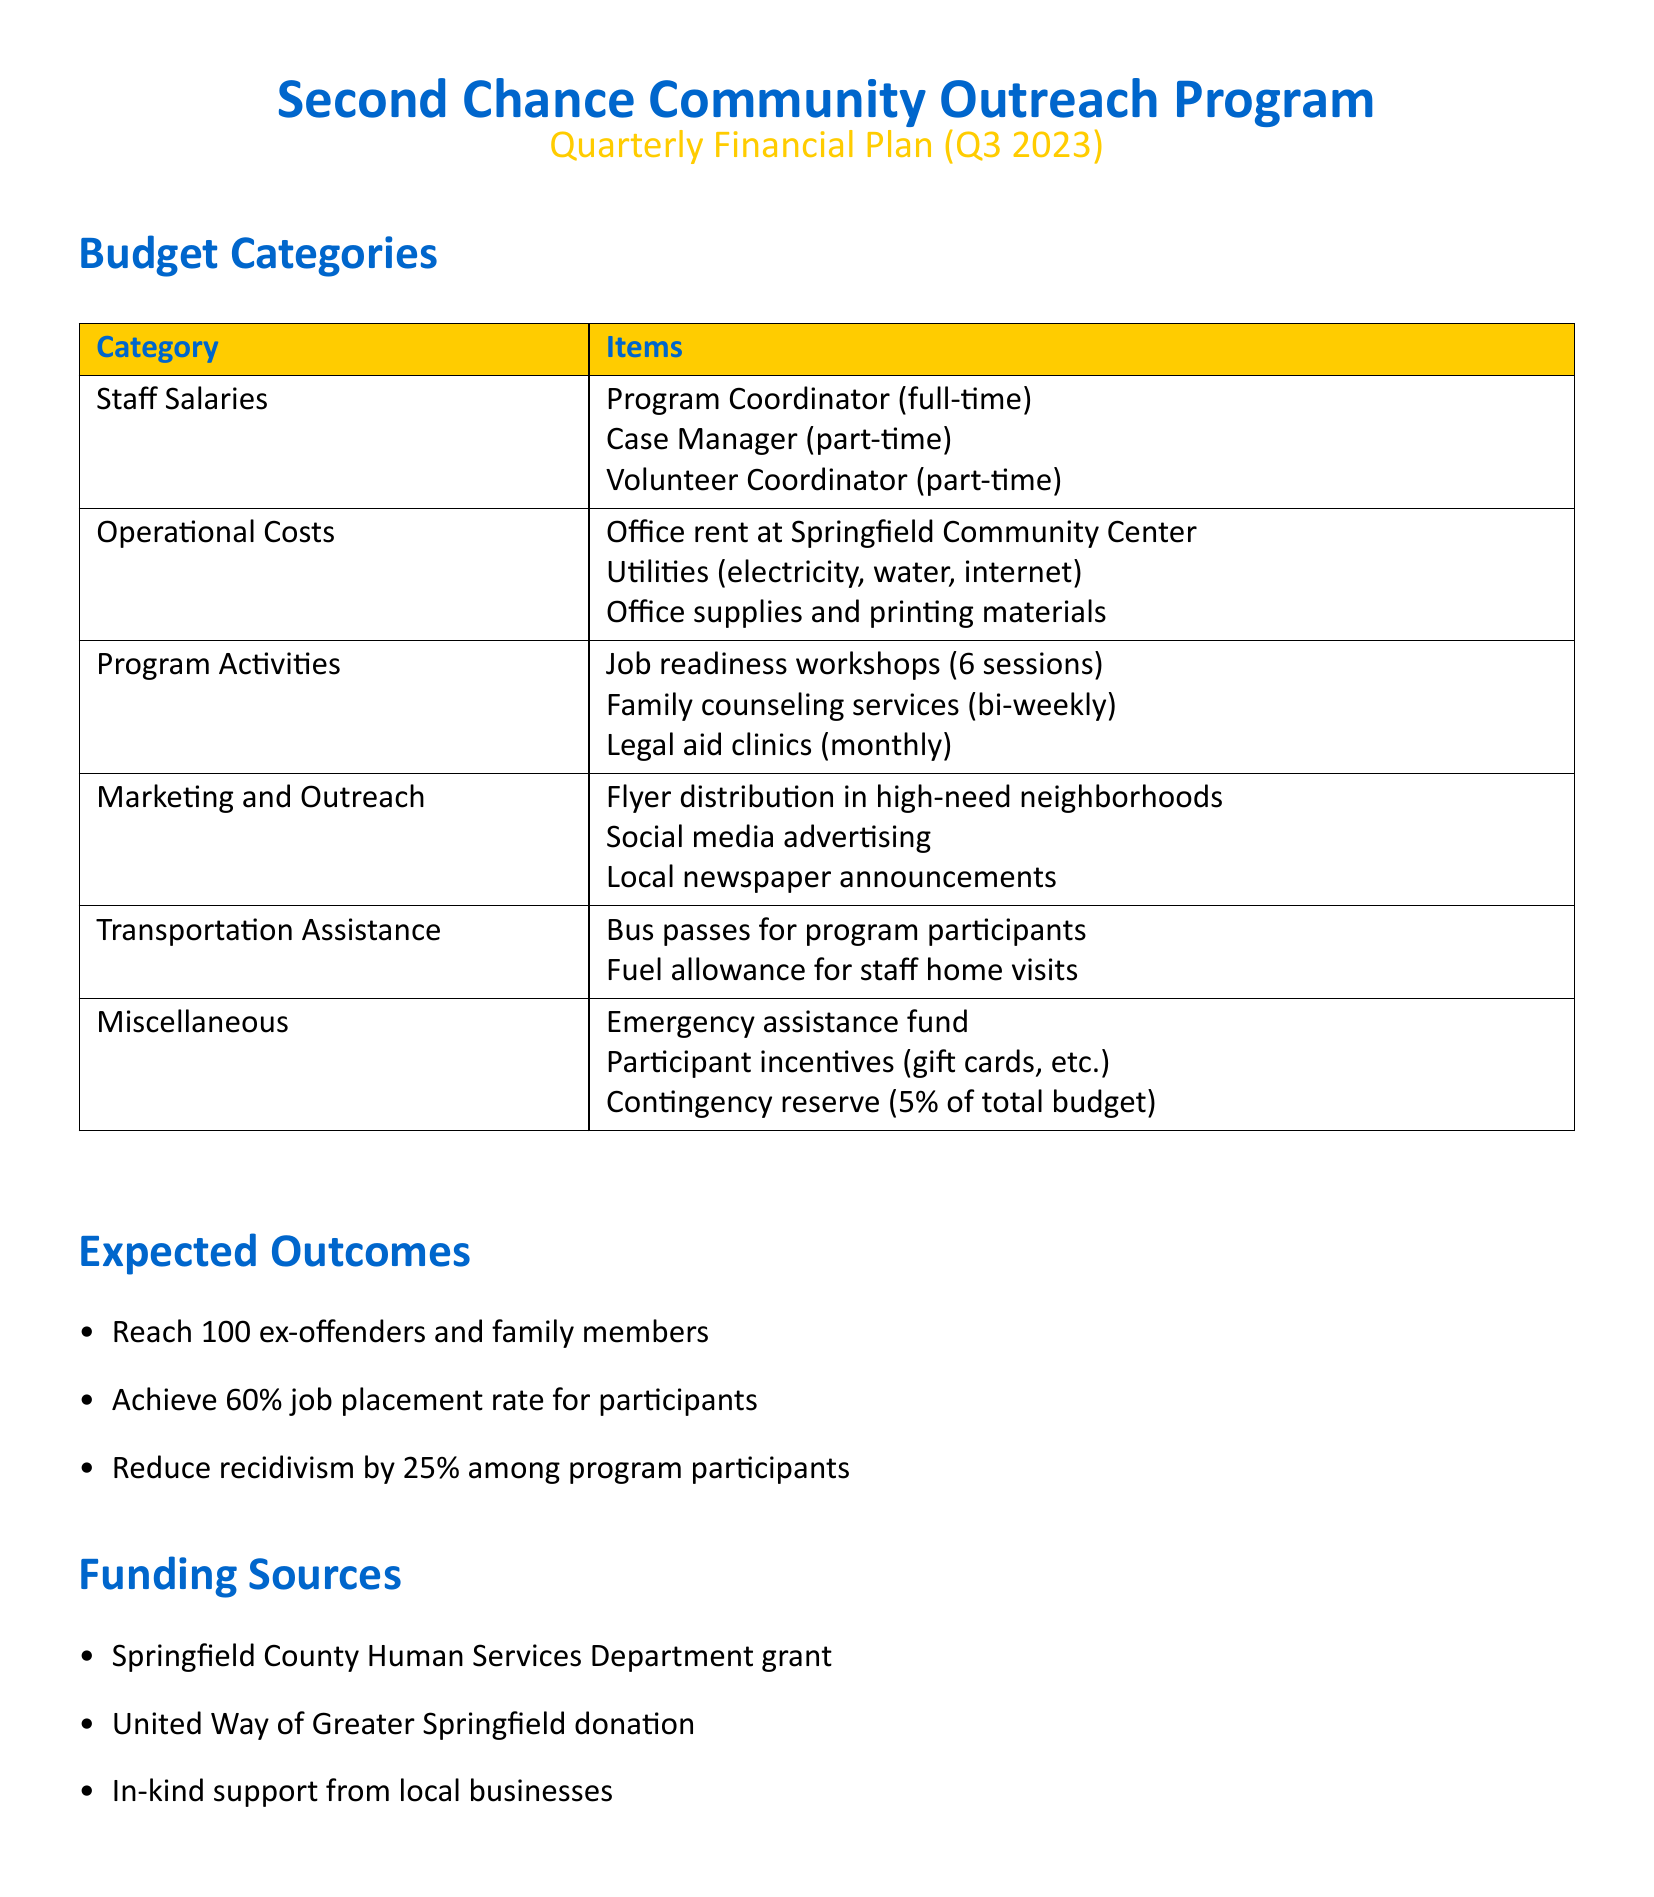What is the total number of job readiness workshops? The document states that there will be 6 sessions of job readiness workshops under the Program Activities section.
Answer: 6 sessions What is the expected job placement rate for participants? The document specifies an expected job placement rate of 60% among participants in the Expected Outcomes section.
Answer: 60% Which department provided a grant for funding? The funding source listed in the document is the Springfield County Human Services Department.
Answer: Springfield County Human Services Department What is included in the operational costs? The operational costs include office rent, utilities, and office supplies, as stated in the budget categories.
Answer: Office rent, utilities, office supplies How often will family counseling services be conducted? The document mentions that family counseling services will be bi-weekly under Program Activities.
Answer: Bi-weekly What is the contingency reserve percentage of the total budget? The contingency reserve is stated as 5% of the total budget in the Miscellaneous section.
Answer: 5% What is one of the expected outcomes regarding recidivism? The document indicates that the program aims to reduce recidivism by 25% among participants.
Answer: 25% Which organization donated to the program? The second funding source mentioned is the United Way of Greater Springfield.
Answer: United Way of Greater Springfield 